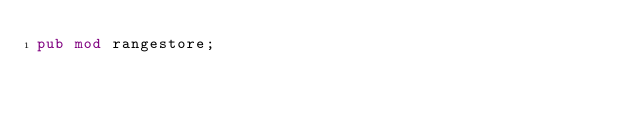<code> <loc_0><loc_0><loc_500><loc_500><_Rust_>pub mod rangestore;
</code> 